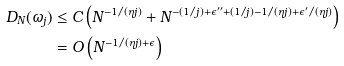Convert formula to latex. <formula><loc_0><loc_0><loc_500><loc_500>D _ { N } ( \omega _ { j } ) & \leq C \left ( N ^ { - 1 / ( \eta j ) } + N ^ { - ( 1 / j ) + \epsilon ^ { \prime \prime } + ( 1 / j ) - 1 / ( \eta j ) + \epsilon ^ { \prime } / ( \eta j ) } \right ) \\ & = O \left ( N ^ { - 1 / ( \eta j ) + \epsilon } \right )</formula> 